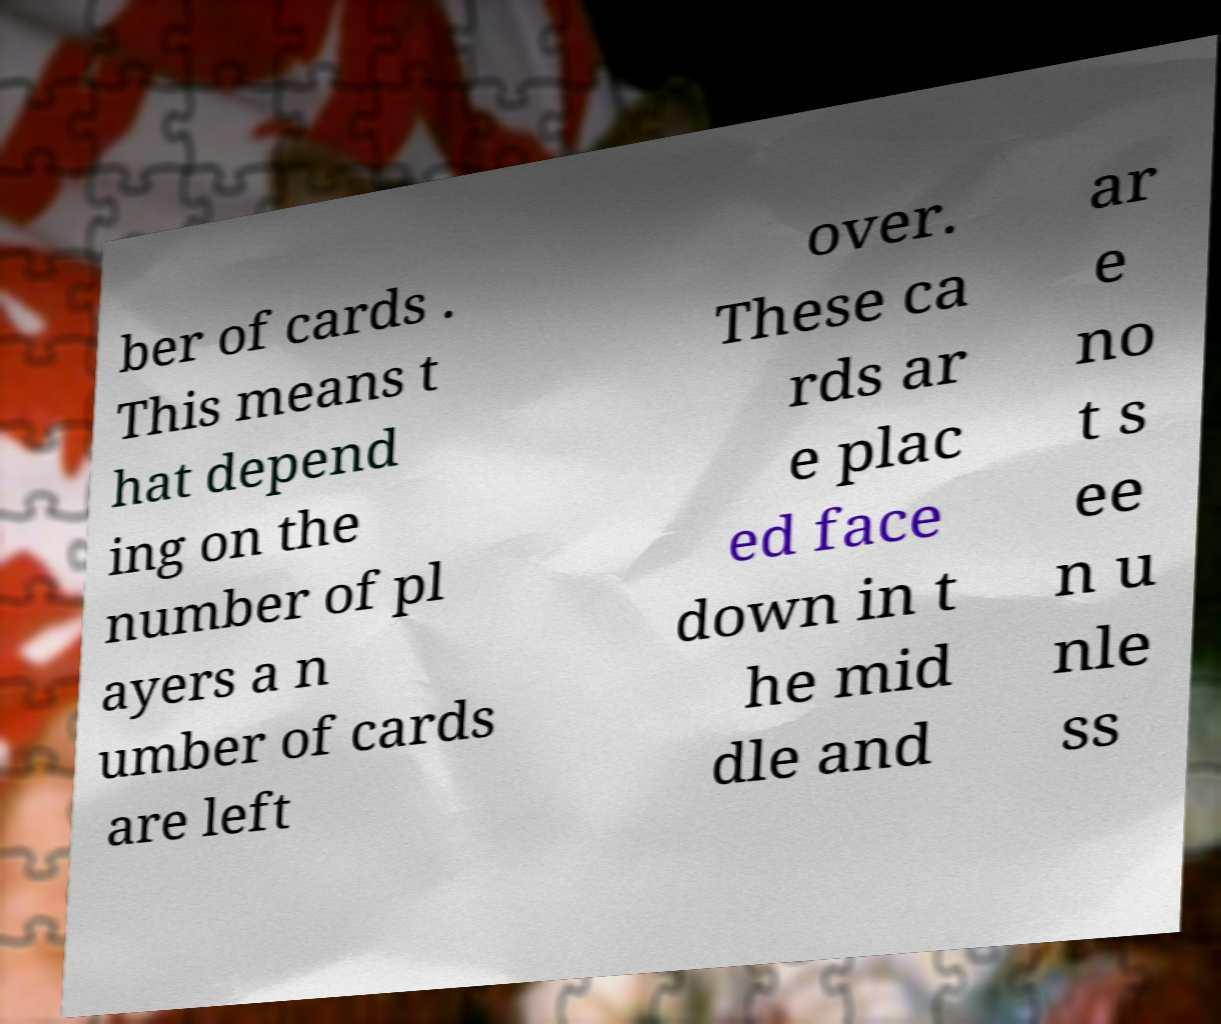Please read and relay the text visible in this image. What does it say? ber of cards . This means t hat depend ing on the number of pl ayers a n umber of cards are left over. These ca rds ar e plac ed face down in t he mid dle and ar e no t s ee n u nle ss 